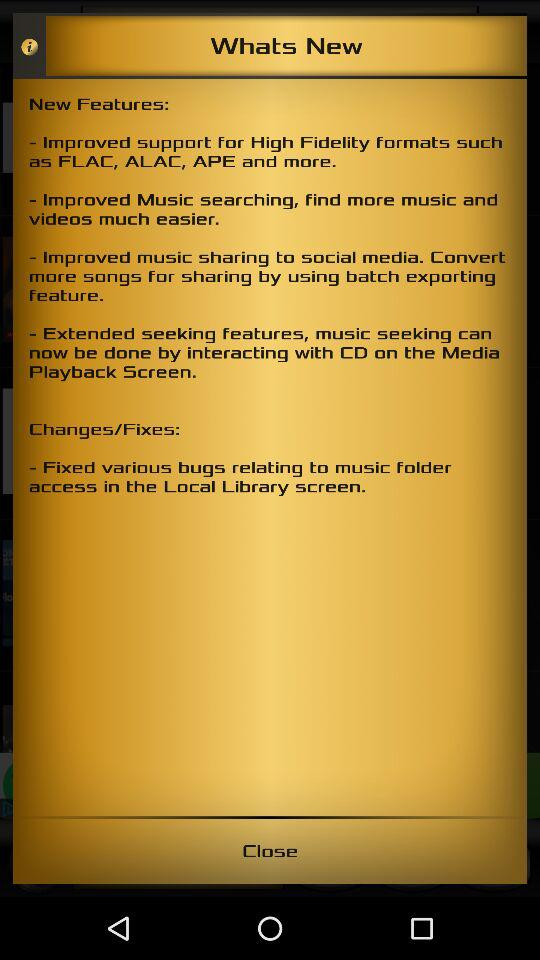How many features have been improved?
Answer the question using a single word or phrase. 4 